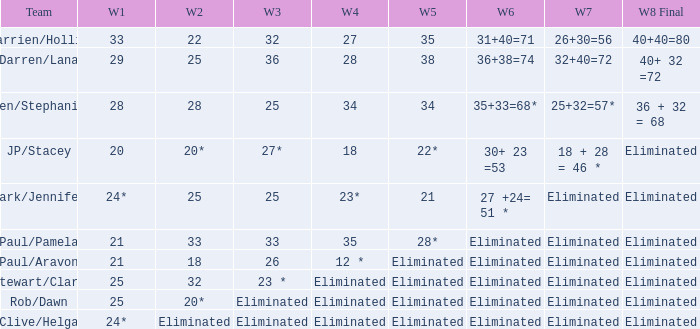Name the week 3 with week 6 of 31+40=71 32.0. 